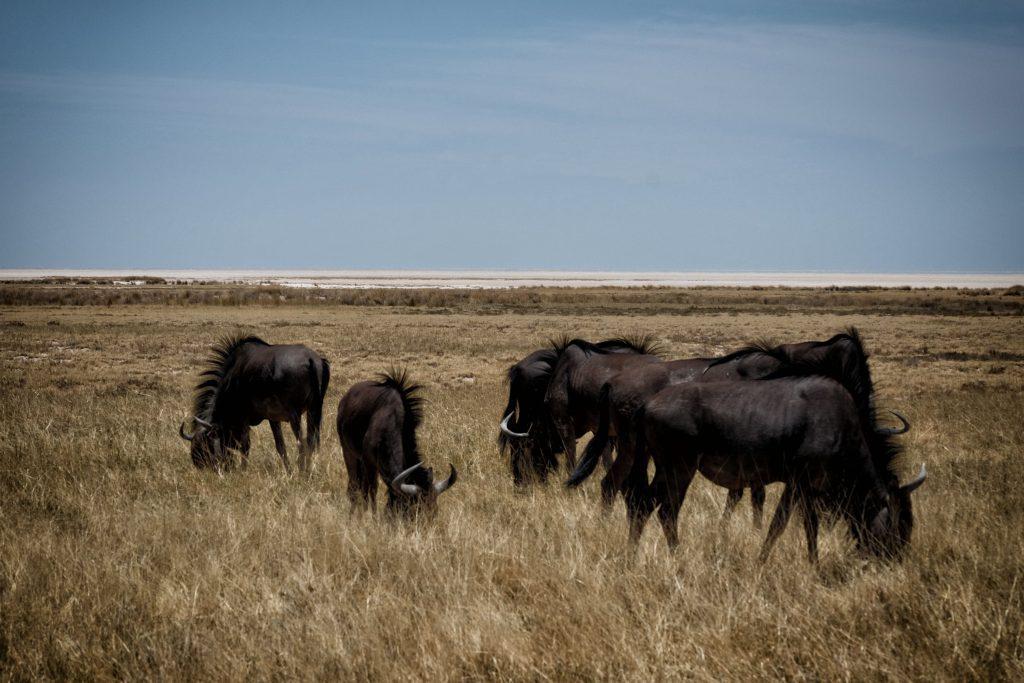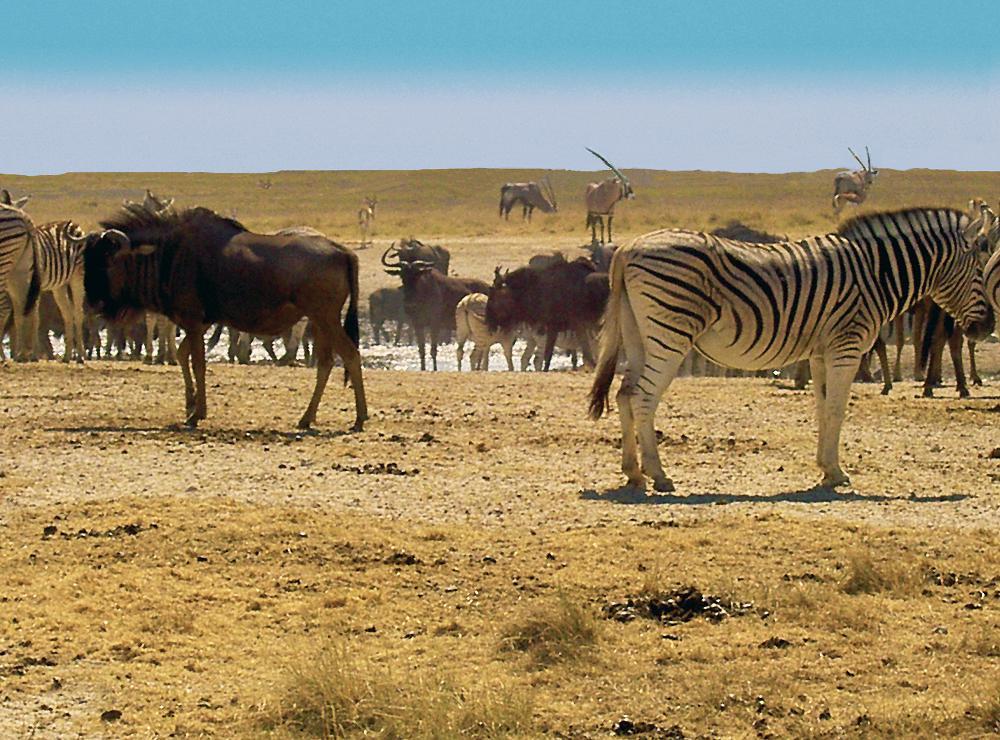The first image is the image on the left, the second image is the image on the right. Assess this claim about the two images: "Zebra are present with horned animals in one image.". Correct or not? Answer yes or no. Yes. 